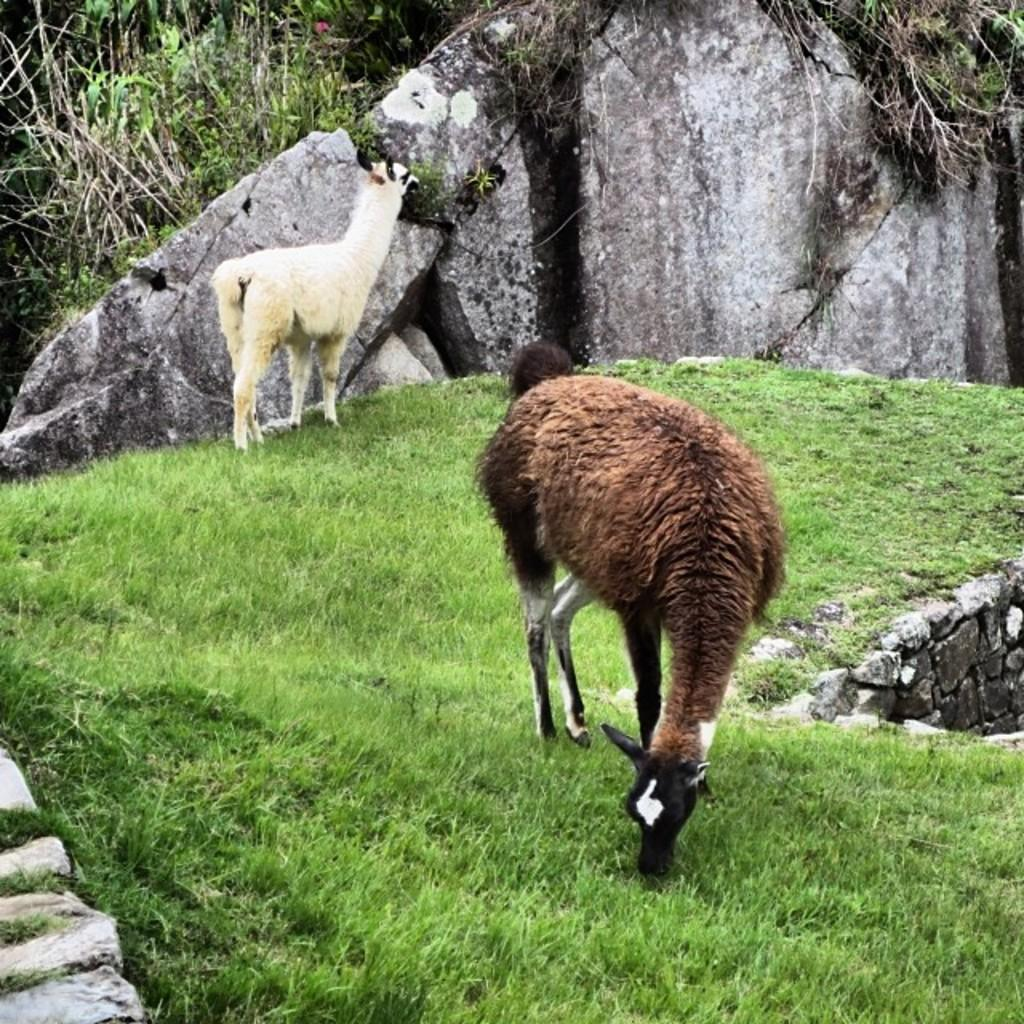What type of living organisms can be seen on the ground in the image? There are animals on the ground in the image. What other elements can be seen in the image besides the animals? There are plants and grass in the image. What type of structure is present in the image? There is a wall in the image. What type of wheel can be seen in the image? There is no wheel present in the image. Can you describe the frog sitting on the grass in the image? There is no frog present in the image. 